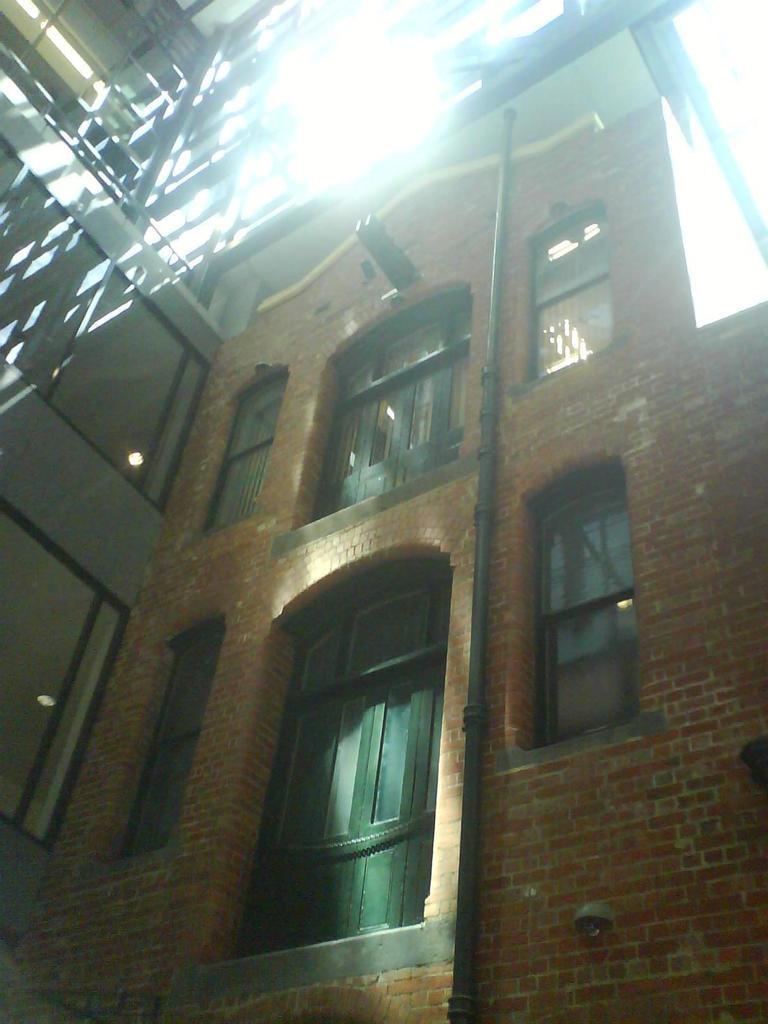Can you describe this image briefly? It is a building there are windows in it. 